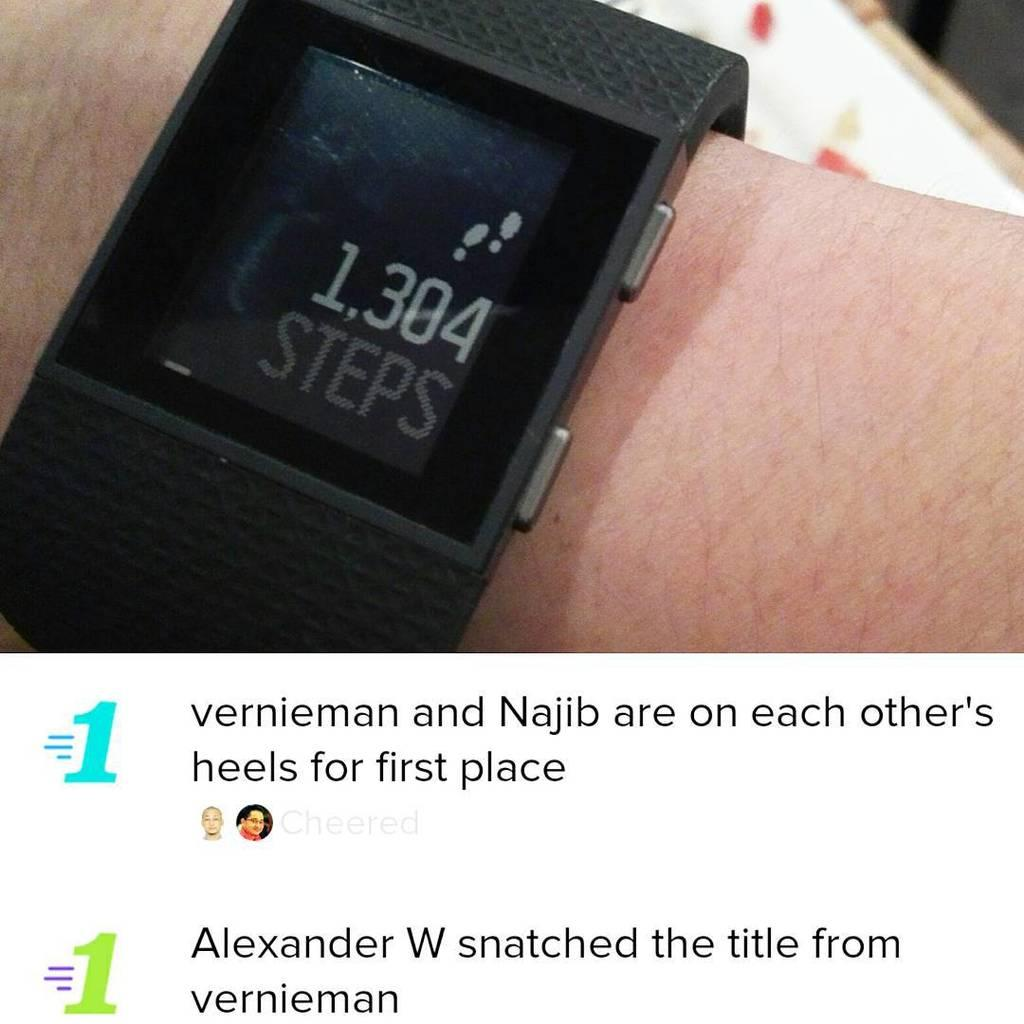<image>
Offer a succinct explanation of the picture presented. A black step tracking watch on step 1304 